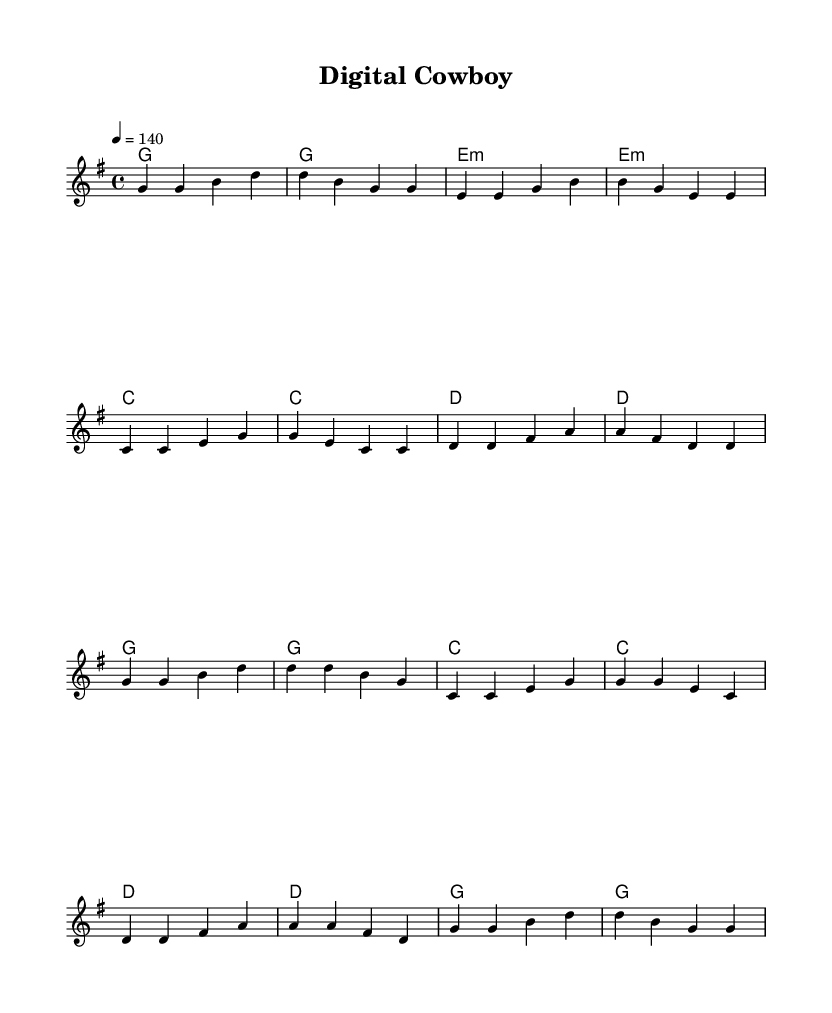What is the key signature of this music? The key signature is G major, which has one sharp (F#). This is indicated at the beginning of the sheet music where the key signature is typically displayed.
Answer: G major What is the time signature of this music? The time signature is 4/4, which means there are four beats in each measure and the quarter note gets one beat. This is noted at the beginning of the score.
Answer: 4/4 What is the tempo marking for this piece? The tempo is indicated as quarter note = 140. This means that there should be 140 quarter note beats per minute when played. This is typically found at the beginning of the music as well.
Answer: 140 How many measures are in the verse section? The verse section consists of eight measures. By counting the individual measures indicated by the vertical lines, we can see that there are eight in the verse.
Answer: Eight What is the name of the song? The title of the song is "Digital Cowboy," which is found in the header section of the sheet music.
Answer: Digital Cowboy What is a prominent theme in the lyrics? A prominent theme in the lyrics is bridging the gap between old-school values and new technology, as seen in phrases discussing boots and code. This central idea shapes the overall narrative of the song.
Answer: Bridging old and new What is the primary instrument indicated for the melody? The primary instrument for the melody is a staff, indicating that it is meant for a melodic instrument or voice to perform. This is commonly represented in the music score layout.
Answer: Staff 